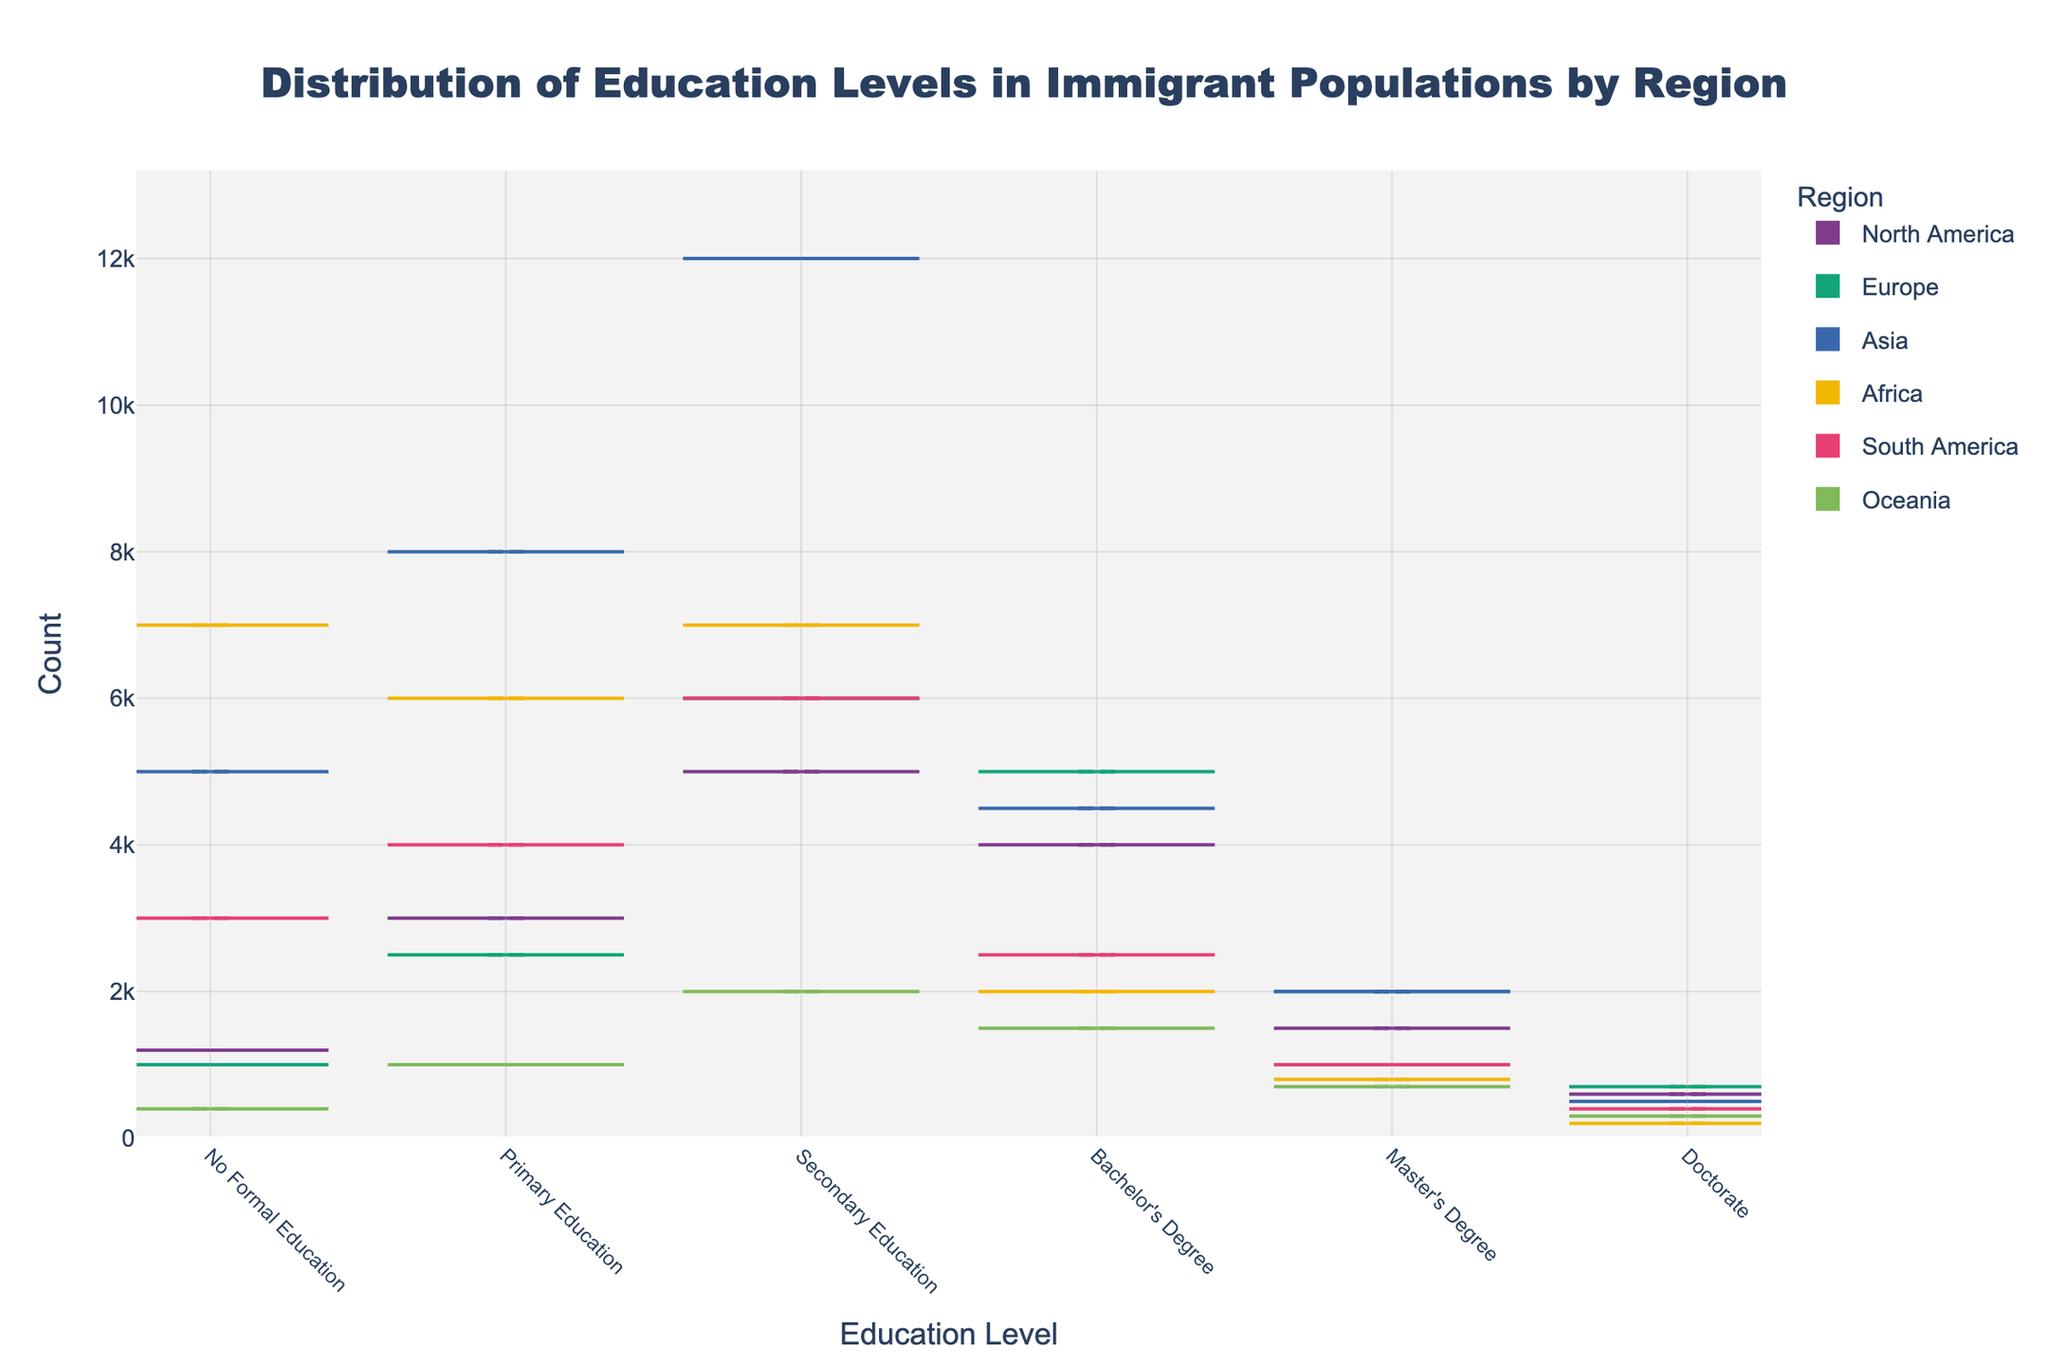What's the title of the figure? The title of the figure can be found at the top center of the plot, usually in bigger and bolder font to distinguish it as the title.
Answer: Distribution of Education Levels in Immigrant Populations by Region Which region has the highest count of immigrants with no formal education? To answer this, look for the widest part of the split violin corresponding to "No Formal Education" on both sides of the chart.
Answer: Africa How does the count of immigrants with a Master's Degree in North America compare to that in Europe? By comparing the two violins for the "Master's Degree" category, we see that North America has slightly fewer immigrants than Europe for this education level.
Answer: North America has fewer What is the sum of immigrants with a Bachelor's Degree and a Master's Degree in Asia? Add the counts of immigrants with a Bachelor's Degree (4500) and a Master's Degree (2000) in Asia. So, 4500 + 2000 = 6500.
Answer: 6500 What is the trend of education levels in Africa? Look at the shape and width of the violins for Africa across different education levels. They peak early at no formal education and then steadily decrease, showing a larger count at lower education levels.
Answer: Higher counts at lower levels Which education level shows the smallest disparity across all regions? Observe the relative widths of the violins for each education level across all regions. "Doctorate" has the smallest overall width and thus the least disparity among regions.
Answer: Doctorate In which region do immigrants with secondary education count more than those with primary education? By comparing the "Primary Education" and "Secondary Education" violins, Europe, Asia, North America, and South America all show wider violins for "Secondary Education" compared to "Primary Education".
Answer: Europe, Asia, North America, South America What's the average count of immigrants with a Doctorate across all regions? Sum the counts of immigrants with a Doctorate from all regions and divide by the number of regions. (600+700+500+200+400+300)/6 = 2700/6 = 450.
Answer: 450 Which region has the broadest range of education levels? Look at the width of the violins across all education levels for each region. Asia has the most considerable spread with significant counts from "No Formal Education" to "Doctorate".
Answer: Asia 